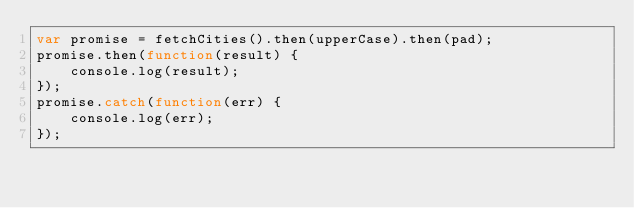Convert code to text. <code><loc_0><loc_0><loc_500><loc_500><_JavaScript_>var promise = fetchCities().then(upperCase).then(pad);
promise.then(function(result) {
    console.log(result);
});
promise.catch(function(err) {
    console.log(err);
});
</code> 